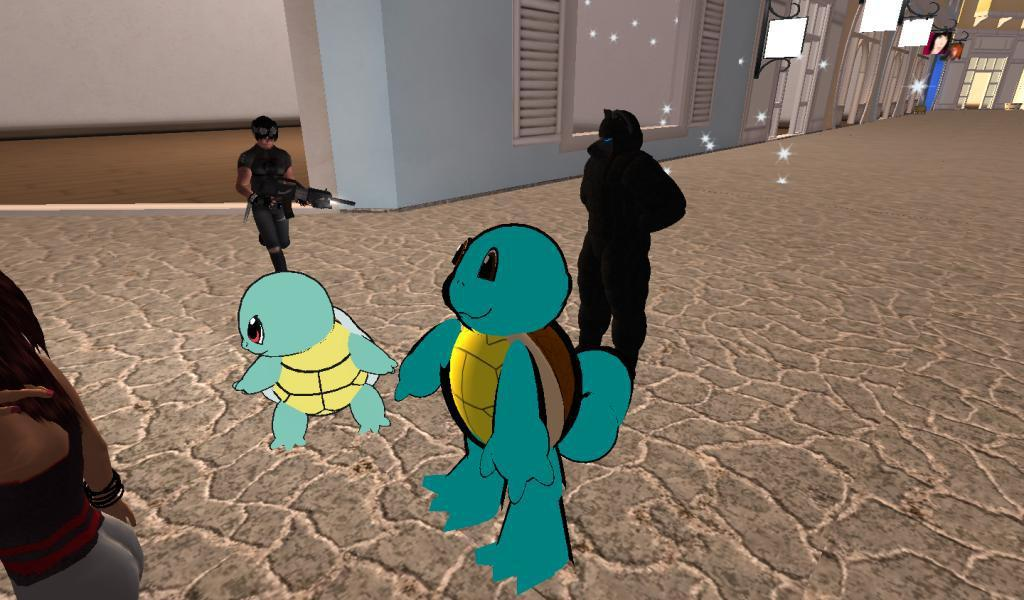What type of content is featured in the image? The image contains cartoons and animation. Can you describe the animated characters in the image? There are animated persons in the image. What is the setting of the image? There is a room depicted in the image. What architectural features can be seen on the right side of the image? There are windows, doors, and a wall on the right side of the image. What is the animated person holding in the image? An animated person is holding a gun in the image. What type of bun is being prepared by the animated person in the image? There is no bun being prepared in the image; the animated person is holding a gun. Can you see any fish swimming in the room depicted in the image? There are no fish visible in the image; it features a room with animated persons and a gun. Is there a yak present in the image? There is no yak present in the image; it contains cartoons and animation with animated persons and a gun. 